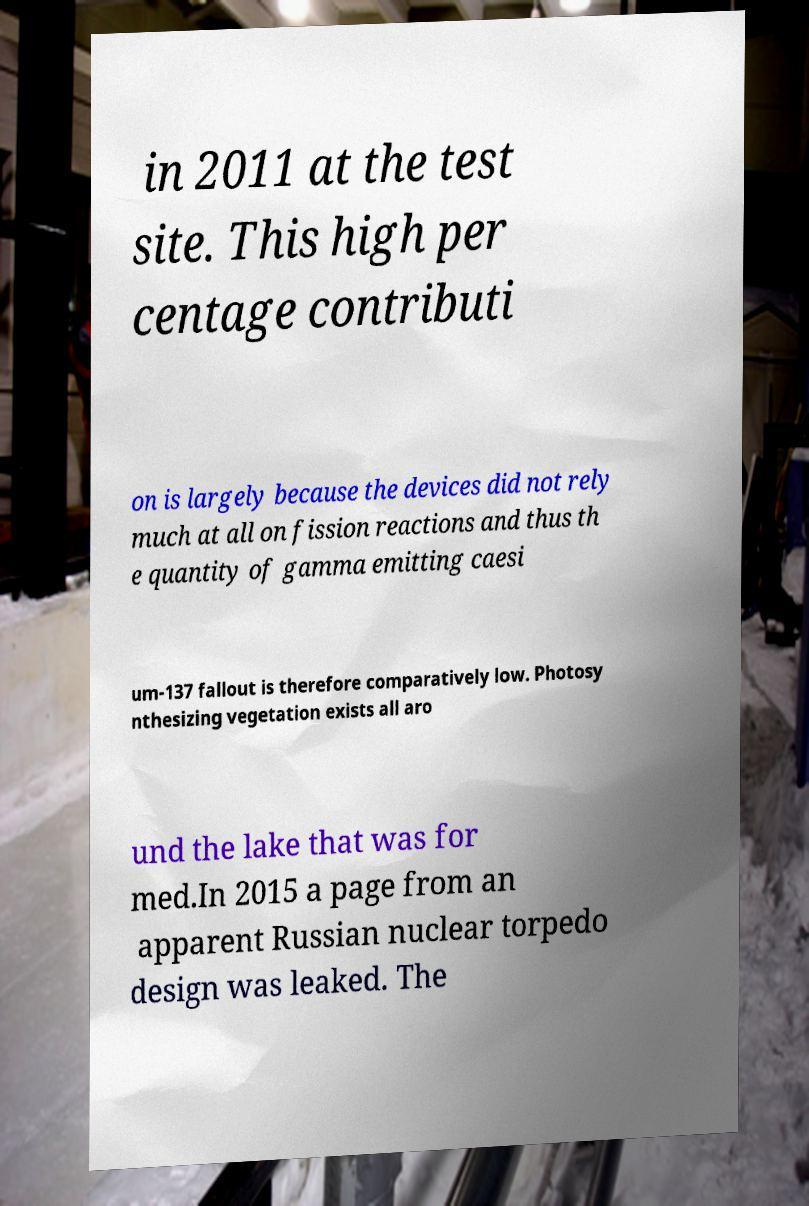Can you accurately transcribe the text from the provided image for me? in 2011 at the test site. This high per centage contributi on is largely because the devices did not rely much at all on fission reactions and thus th e quantity of gamma emitting caesi um-137 fallout is therefore comparatively low. Photosy nthesizing vegetation exists all aro und the lake that was for med.In 2015 a page from an apparent Russian nuclear torpedo design was leaked. The 